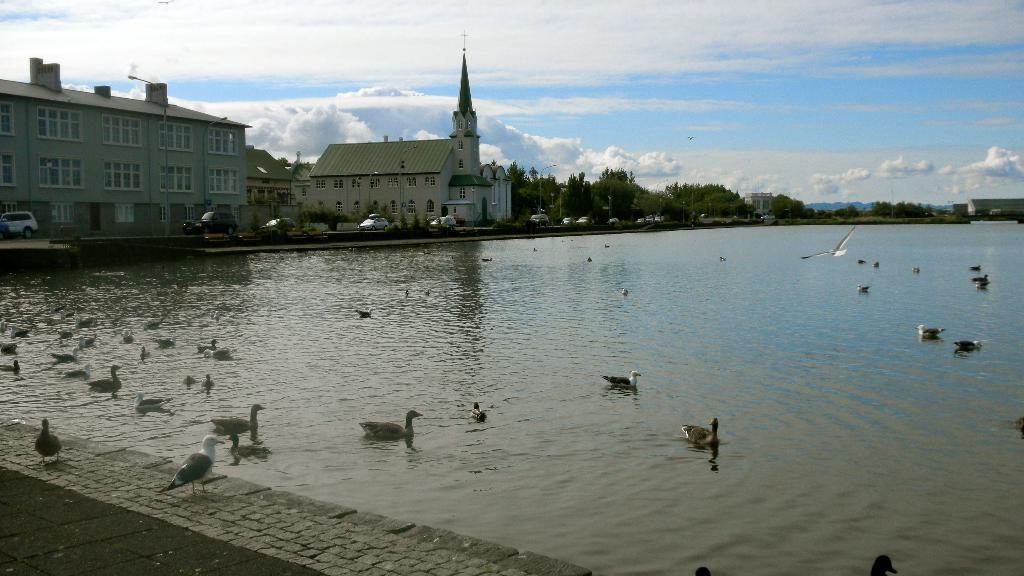How would you summarize this image in a sentence or two? In this picture there are buildings and trees and poles and there are vehicles on the road and at the back there is a mountain. At the top there is sky and there are clouds. At the bottom there are birds on the water and there are two birds on the pavement and there is a bird flying. 